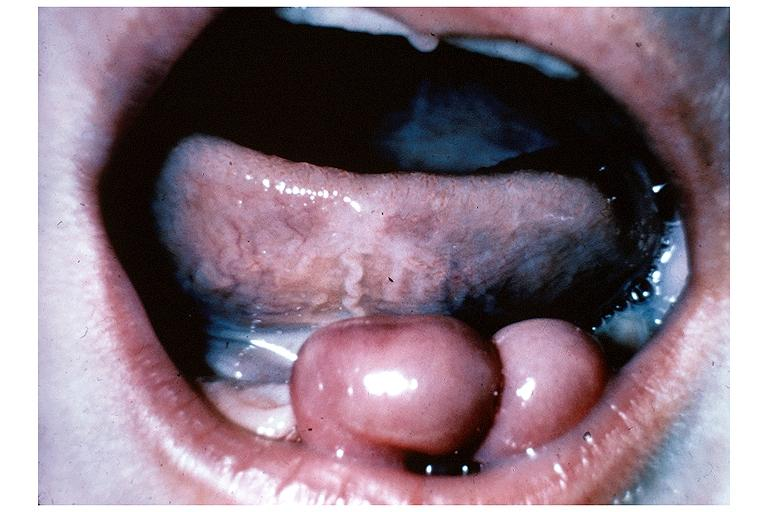does this image show congenital epulis?
Answer the question using a single word or phrase. Yes 